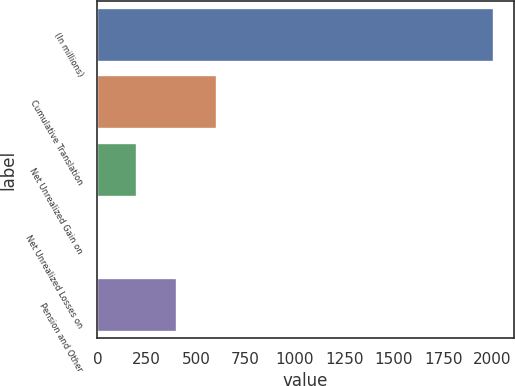Convert chart to OTSL. <chart><loc_0><loc_0><loc_500><loc_500><bar_chart><fcel>(In millions)<fcel>Cumulative Translation<fcel>Net Unrealized Gain on<fcel>Net Unrealized Losses on<fcel>Pension and Other<nl><fcel>2007<fcel>603.08<fcel>201.96<fcel>1.4<fcel>402.52<nl></chart> 